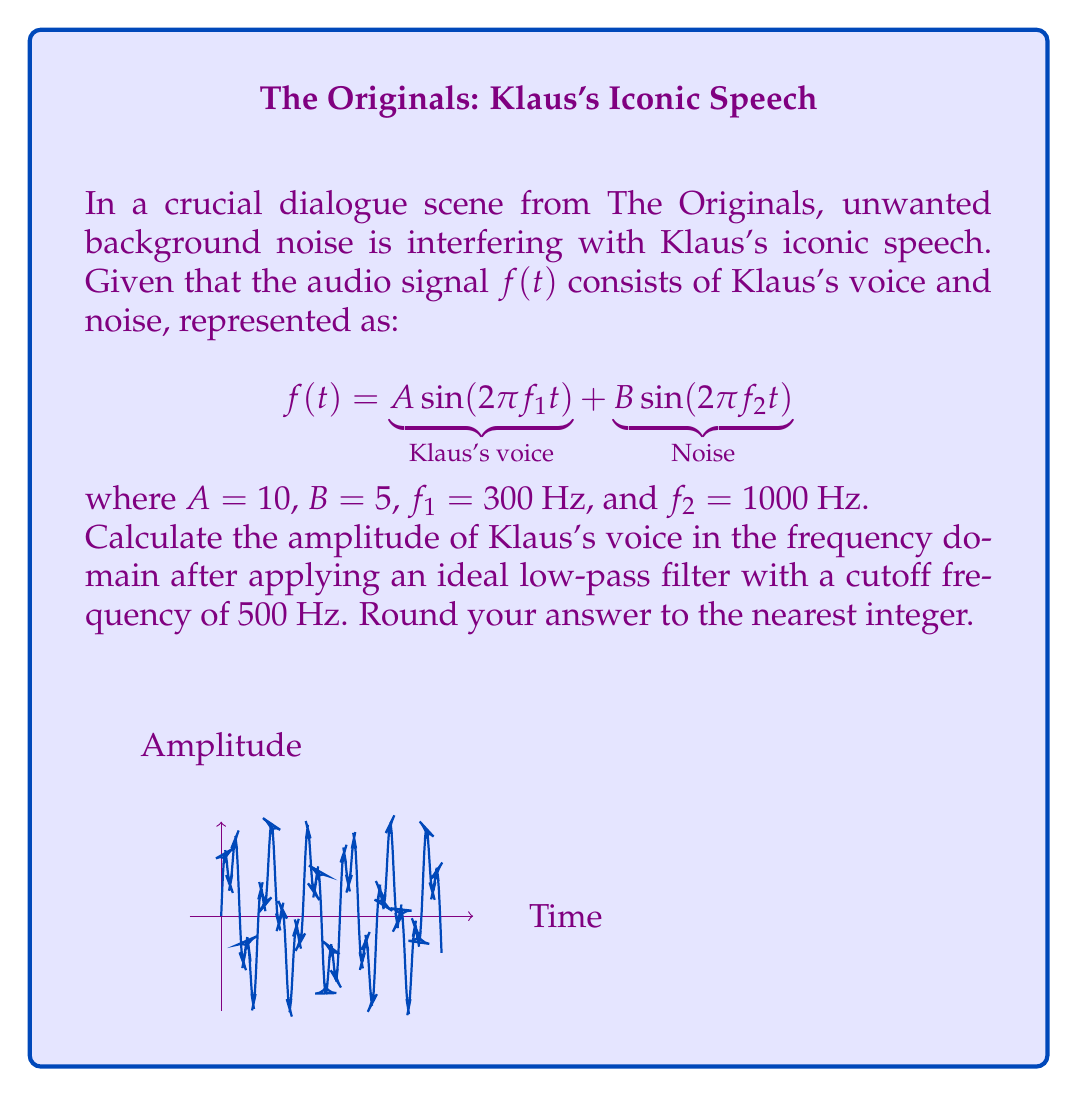Can you solve this math problem? Let's approach this step-by-step:

1) First, we need to find the Fourier transform of $f(t)$. The Fourier transform of a sine wave $A \sin(2\pi f t)$ is given by:

   $$\mathcal{F}\{A \sin(2\pi f t)\} = \frac{iA}{2}[\delta(f') - \delta(f'+f)] - \frac{iA}{2}[\delta(f'-f) - \delta(f')]$$

   where $\delta$ is the Dirac delta function and $f'$ is the frequency variable in the Fourier domain.

2) Applying this to our signal:

   $$\mathcal{F}\{f(t)\} = \frac{i10}{2}[\delta(f') - \delta(f'+300)] - \frac{i10}{2}[\delta(f'-300) - \delta(f')] \\
   + \frac{i5}{2}[\delta(f') - \delta(f'+1000)] - \frac{i5}{2}[\delta(f'-1000) - \delta(f')]$$

3) The amplitude spectrum is the magnitude of this Fourier transform:

   $$|\mathcal{F}\{f(t)\}| = 10\delta(f'-300) + 5\delta(f'-1000)$$

4) Applying an ideal low-pass filter with a cutoff frequency of 500 Hz will eliminate all frequencies above 500 Hz. This means the noise component at 1000 Hz will be removed:

   $$|\mathcal{F}\{f(t)\}|_{\text{filtered}} = 10\delta(f'-300)$$

5) The amplitude of Klaus's voice in the frequency domain is therefore 10.

6) Rounding to the nearest integer: 10.
Answer: 10 